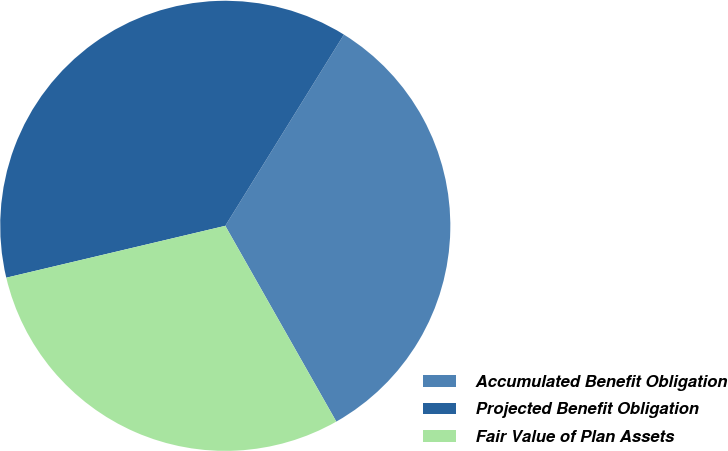Convert chart. <chart><loc_0><loc_0><loc_500><loc_500><pie_chart><fcel>Accumulated Benefit Obligation<fcel>Projected Benefit Obligation<fcel>Fair Value of Plan Assets<nl><fcel>32.95%<fcel>37.54%<fcel>29.51%<nl></chart> 